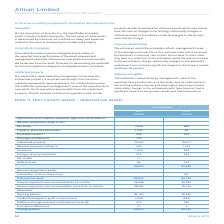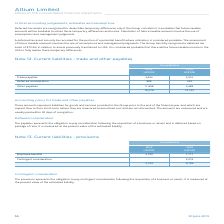According to Altium Limited's financial document, What is the Tax losses for 2019? According to the financial document, 2,068 (in thousands). The relevant text states: "Tax losses 2,068 688..." Also, When are Deferred tax assets recognized? only if the Group considers it is probable that future taxable amounts will be available to utilise those temporary differences and losses. The document states: "e recognised for deductible temporary differences only if the Group considers it is probable that future taxable amounts will be available to utilise ..." Also, How are future taxable amounts assessed? The document shows two values: use of assumptions and management judgments. From the document: "assumptions and management judgments. of future taxable amounts involves the use of assumptions and management judgments. The Group has fully recognis..." Also, can you calculate: What is the percentage increase in the deferred tax assets from 2018 to 2019? To answer this question, I need to perform calculations using the financial data. The calculation is: (84,873-82,120)/82,120, which equals 3.35 (percentage). This is based on the information: "Deferred tax asset 84,873 82,120 Deferred tax asset 84,873 82,120..." The key data points involved are: 82,120, 84,873. Also, can you calculate: What is the percentage increase in amount of intellectual property from 2018 to 2019? To answer this question, I need to perform calculations using the financial data. The calculation is: (79,260-79,011)/79,011, which equals 0.32 (percentage). This is based on the information: "Intellectual property 79,260 79,011 Intellectual property 79,260 79,011..." The key data points involved are: 79,011, 79,260. Additionally, Which year had the higher Closing balance?  According to the financial document, 2019. The relevant text states: "30 June 2019 54..." 